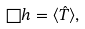Convert formula to latex. <formula><loc_0><loc_0><loc_500><loc_500>\Box h = \langle \hat { T } \rangle ,</formula> 